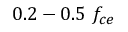Convert formula to latex. <formula><loc_0><loc_0><loc_500><loc_500>0 . 2 - 0 . 5 \ f _ { c e }</formula> 